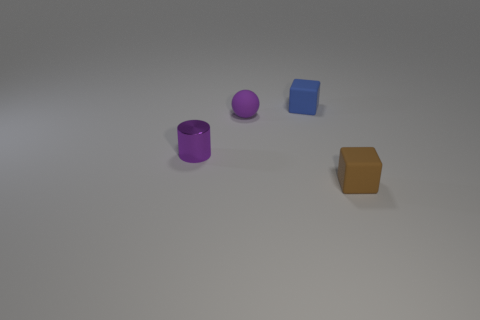Do the matte object that is in front of the tiny purple metal cylinder and the object behind the purple matte ball have the same shape?
Provide a succinct answer. Yes. There is a small brown matte object; is it the same shape as the tiny blue thing that is behind the cylinder?
Your answer should be compact. Yes. Do the shiny cylinder and the tiny matte object on the left side of the blue rubber cube have the same color?
Keep it short and to the point. Yes. There is a small metal thing that is left of the small matte ball; is it the same color as the tiny matte thing left of the blue block?
Your answer should be very brief. Yes. What material is the small cube left of the rubber object that is in front of the tiny purple thing that is behind the purple shiny cylinder made of?
Give a very brief answer. Rubber. Does the purple matte thing have the same shape as the brown object?
Provide a short and direct response. No. There is another thing that is the same shape as the tiny brown matte thing; what is its material?
Provide a short and direct response. Rubber. How many metal things have the same color as the tiny matte sphere?
Make the answer very short. 1. What size is the blue object that is made of the same material as the brown block?
Keep it short and to the point. Small. How many purple things are blocks or tiny cylinders?
Give a very brief answer. 1. 